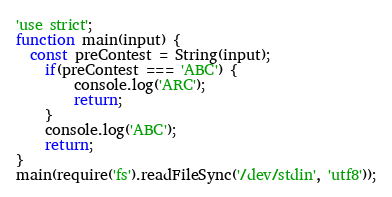<code> <loc_0><loc_0><loc_500><loc_500><_JavaScript_>'use strict';
function main(input) {
  const preContest = String(input);
	if(preContest === 'ABC') {
		console.log('ARC');
      	return;
    }
	console.log('ABC');
	return;
}
main(require('fs').readFileSync('/dev/stdin', 'utf8'));</code> 